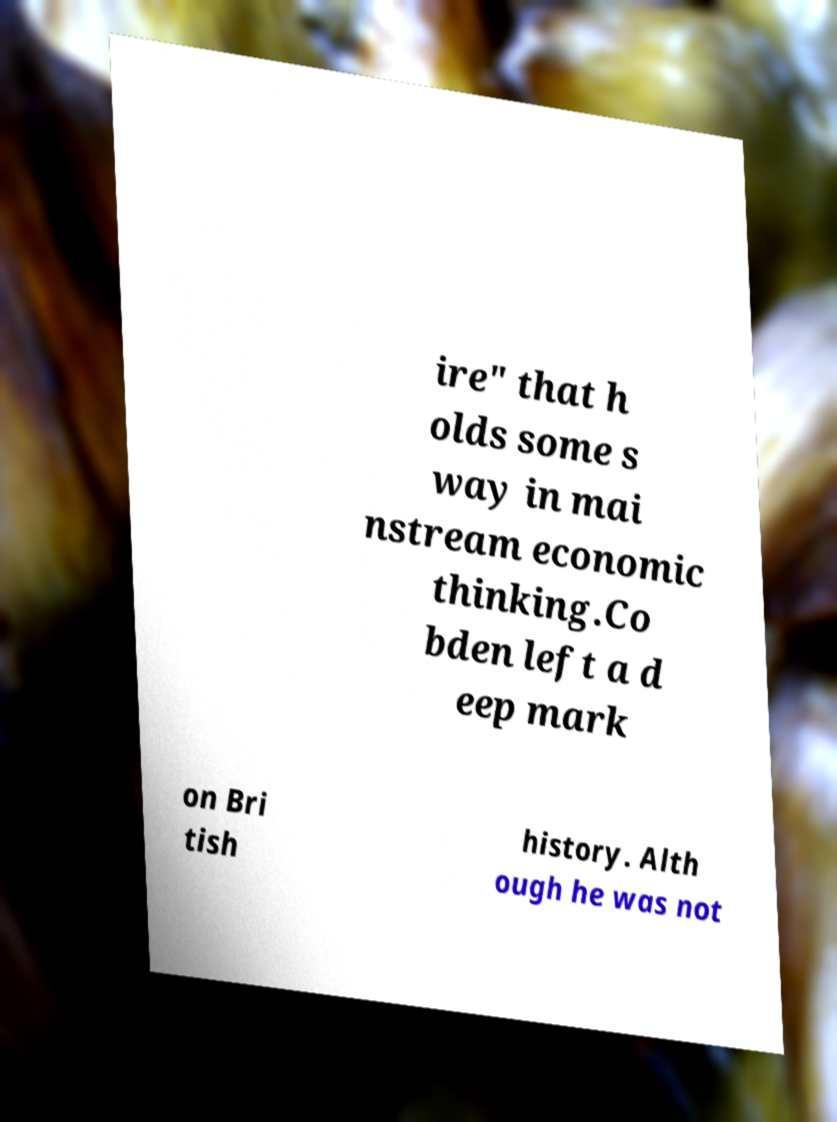Can you read and provide the text displayed in the image?This photo seems to have some interesting text. Can you extract and type it out for me? ire" that h olds some s way in mai nstream economic thinking.Co bden left a d eep mark on Bri tish history. Alth ough he was not 